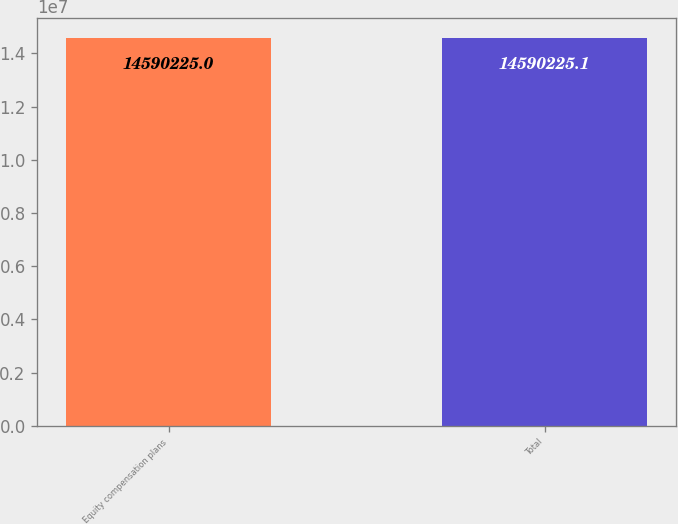Convert chart to OTSL. <chart><loc_0><loc_0><loc_500><loc_500><bar_chart><fcel>Equity compensation plans<fcel>Total<nl><fcel>1.45902e+07<fcel>1.45902e+07<nl></chart> 